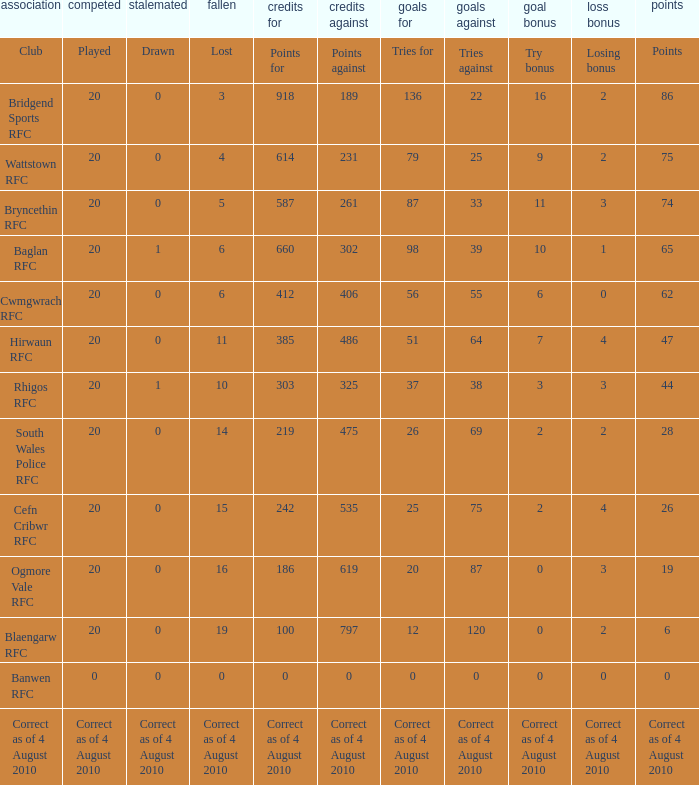What is the points against when the losing bonus is 0 and the club is banwen rfc? 0.0. 